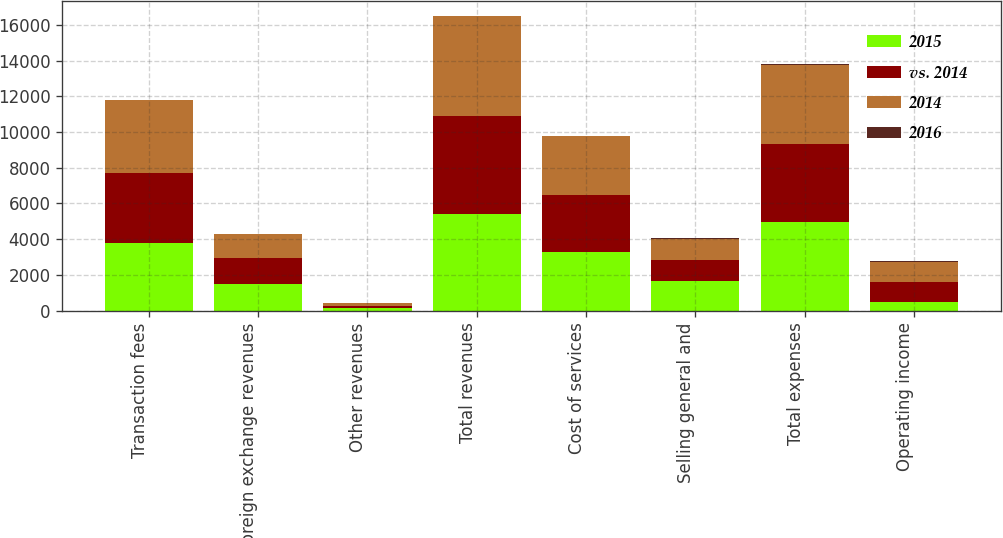Convert chart to OTSL. <chart><loc_0><loc_0><loc_500><loc_500><stacked_bar_chart><ecel><fcel>Transaction fees<fcel>Foreign exchange revenues<fcel>Other revenues<fcel>Total revenues<fcel>Cost of services<fcel>Selling general and<fcel>Total expenses<fcel>Operating income<nl><fcel>2015<fcel>3795.1<fcel>1490.2<fcel>137.6<fcel>5422.9<fcel>3270<fcel>1669.2<fcel>4939.2<fcel>483.7<nl><fcel>vs. 2014<fcel>3915.6<fcel>1436.2<fcel>131.9<fcel>5483.7<fcel>3199.4<fcel>1174.9<fcel>4374.3<fcel>1109.4<nl><fcel>2014<fcel>4083.6<fcel>1386.3<fcel>137.3<fcel>5607.2<fcel>3297.4<fcel>1169.3<fcel>4466.7<fcel>1140.5<nl><fcel>2016<fcel>3<fcel>4<fcel>4<fcel>1<fcel>2<fcel>42<fcel>13<fcel>56<nl></chart> 